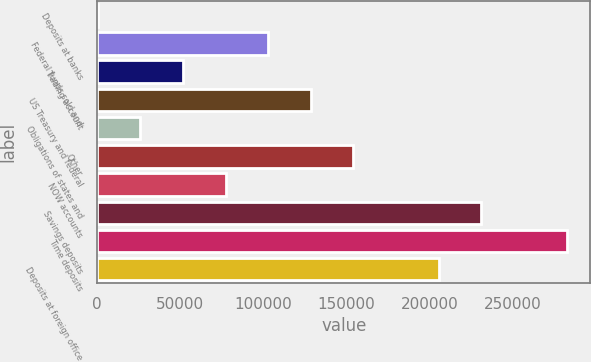Convert chart. <chart><loc_0><loc_0><loc_500><loc_500><bar_chart><fcel>Deposits at banks<fcel>Federal funds sold and<fcel>Trading account<fcel>US Treasury and federal<fcel>Obligations of states and<fcel>Other<fcel>NOW accounts<fcel>Savings deposits<fcel>Time deposits<fcel>Deposits at foreign office<nl><fcel>203<fcel>102815<fcel>51508.8<fcel>128468<fcel>25855.9<fcel>154120<fcel>77161.7<fcel>231079<fcel>282385<fcel>205426<nl></chart> 